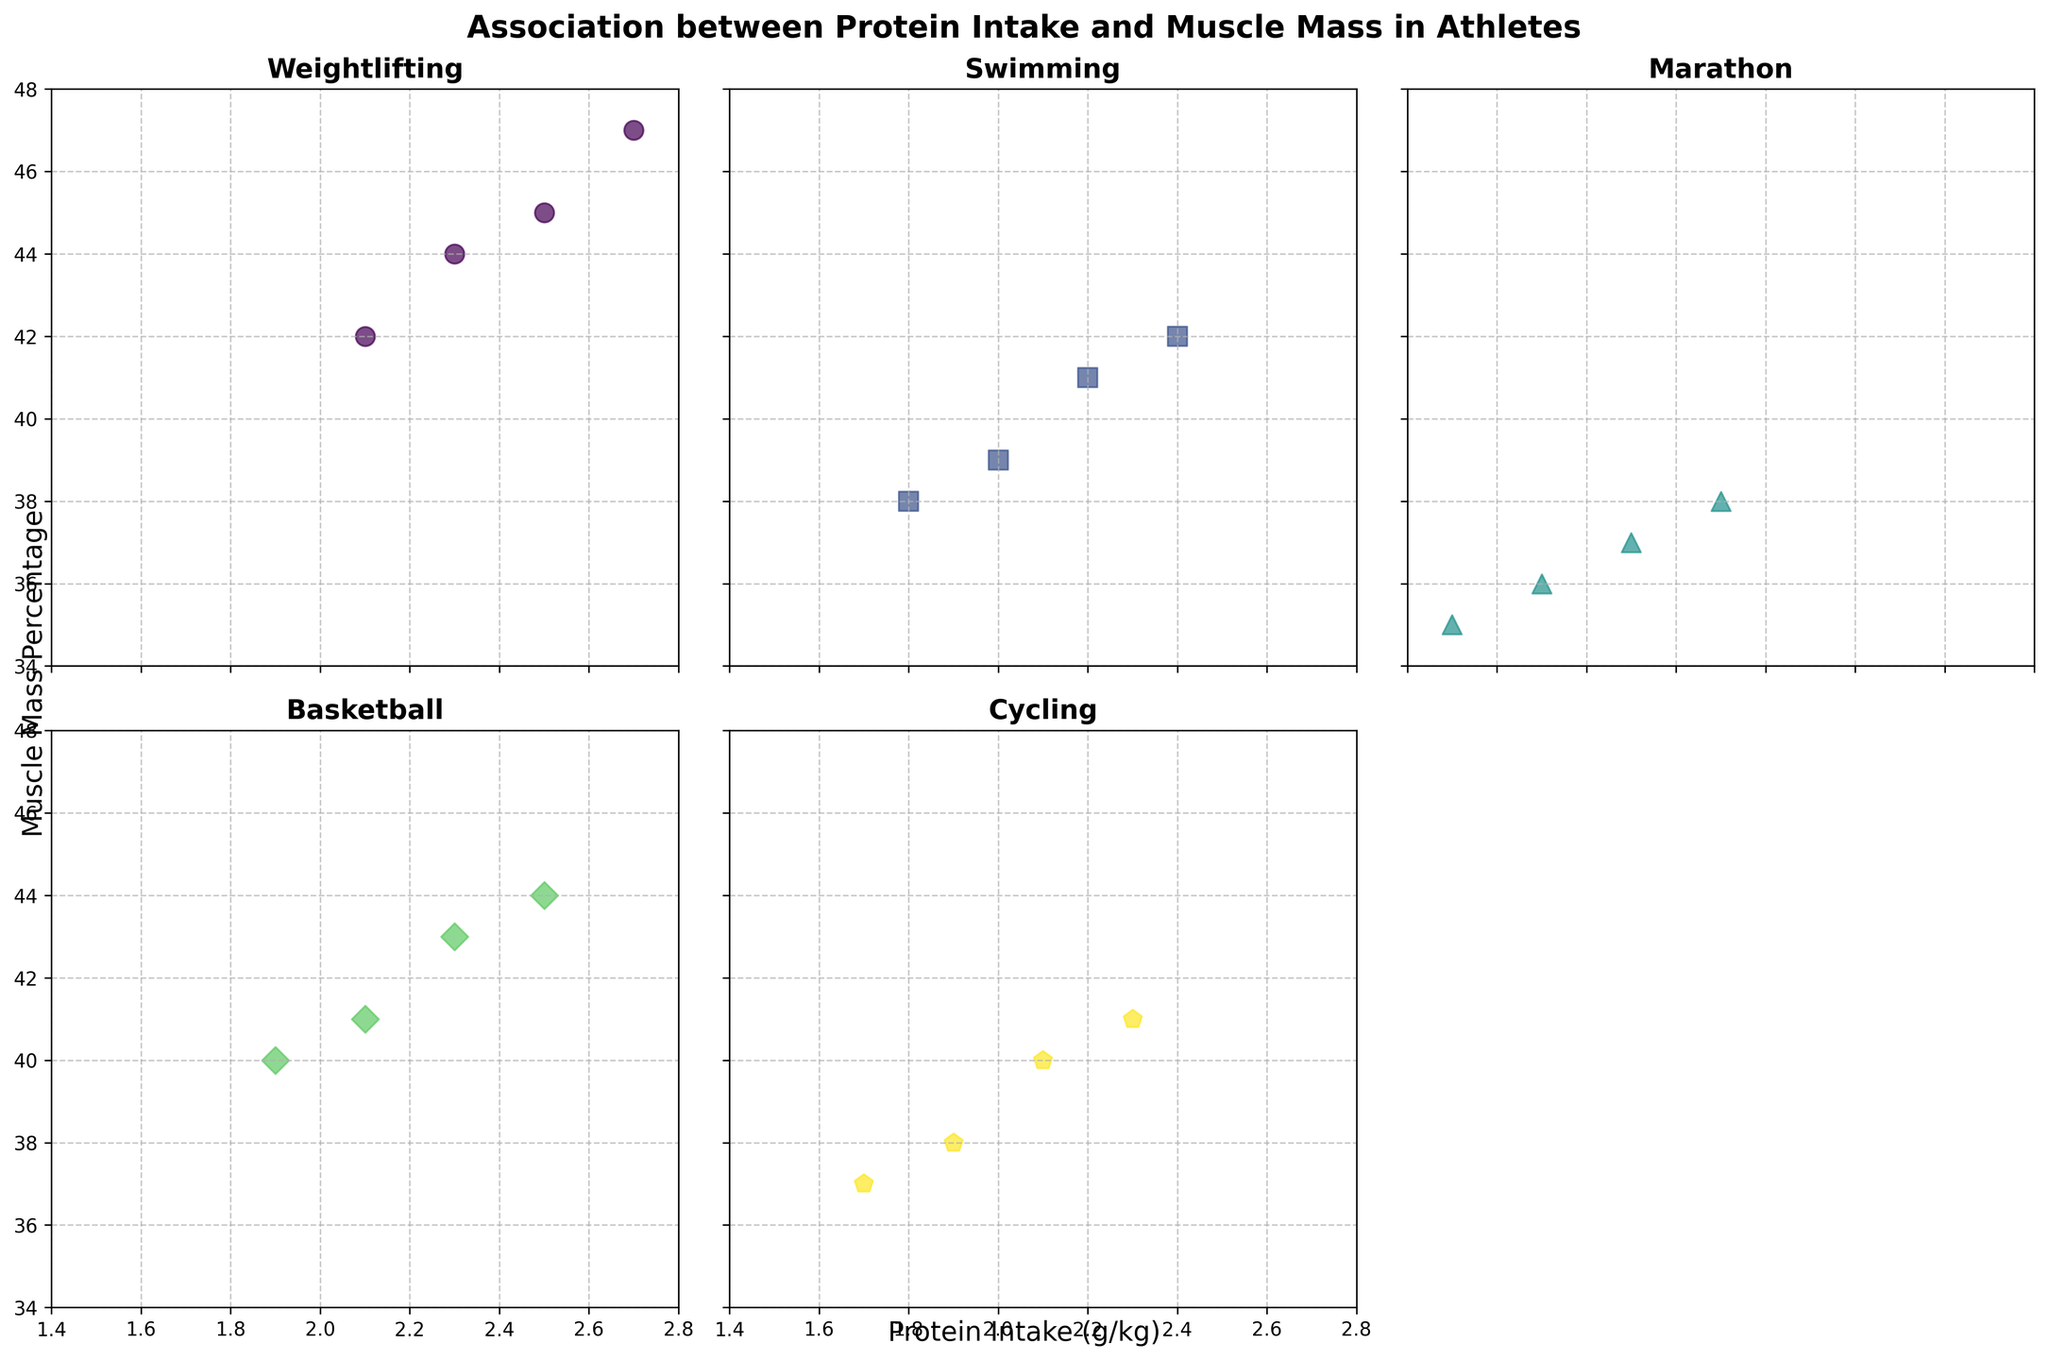What is the title of the figure? The title of the figure is displayed prominently at the top of the plot area.
Answer: Association between Protein Intake and Muscle Mass in Athletes What range of protein intake is displayed on the x-axis? The x-axis in each subplot has a numerical range that provides the minimum and maximum values of protein intake.
Answer: 1.4 to 2.8 How many sports disciplines are shown in the subplots? By counting the individual titles of each scatter plot, we can determine the number of sports disciplines covered.
Answer: Five Which sport has the highest muscle mass percentage in its subgroup? By looking at the highest y-value for muscle mass percentage in each subplot, we can identify which sport contains the highest value.
Answer: Weightlifting Is there a trend between protein intake and muscle mass percentage in weightlifters? By visually assessing the scatter plot for weightlifting, we can observe if there is an upward or downward trend in the data points.
Answer: Yes, an upward trend Which sport subgroup appears to have the widest range of muscle mass percentages? By comparing the spread of data points along the y-axis across the different sports subplots, we can determine which one spans the widest range of muscle mass percentages.
Answer: Weightlifting Does any sport show a negative relationship between protein intake and muscle mass percentage? Observing each scatter plot's trend, we can see if any sport shows a downward trend as protein intake increases.
Answer: No Comparing weightlifting and swimming, which one shows a stronger association between protein intake and muscle mass percentage? By comparing the visual clarity of the trend and the concentration of the data points in the weightlifting and swimming subplots, we can judge which one has a more evident association.
Answer: Weightlifting What is the muscle mass percentage for marathon runners with a protein intake of 2.1 g/kg? By locating the data point in the marathon subplot where the x-value is 2.1, we can find the corresponding y-value for muscle mass percentage.
Answer: 38 Which sport has the least data points displayed? By counting the number of data points in each subplot, we can determine which sport has the fewest points.
Answer: Weightlifting 